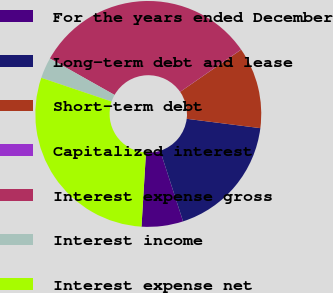Convert chart to OTSL. <chart><loc_0><loc_0><loc_500><loc_500><pie_chart><fcel>For the years ended December<fcel>Long-term debt and lease<fcel>Short-term debt<fcel>Capitalized interest<fcel>Interest expense gross<fcel>Interest income<fcel>Interest expense net<nl><fcel>5.94%<fcel>18.01%<fcel>11.65%<fcel>0.02%<fcel>32.18%<fcel>2.98%<fcel>29.22%<nl></chart> 